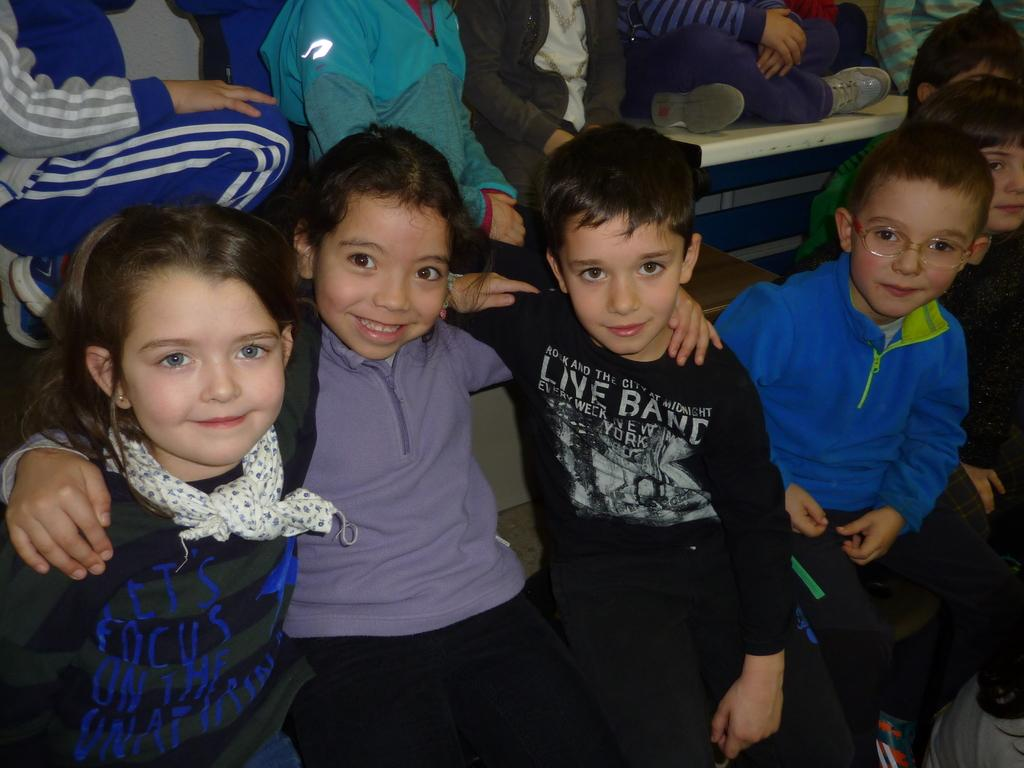What is the main subject of the image? The main subject of the image is a group of children. Can you describe any specific details about the children? Yes, a boy on the right side is wearing glasses (specs), and a girl on the left side is wearing a scarf. What type of vegetable is being used as a curtain in the image? There is no vegetable being used as a curtain in the image; it is a group of children sitting together. 